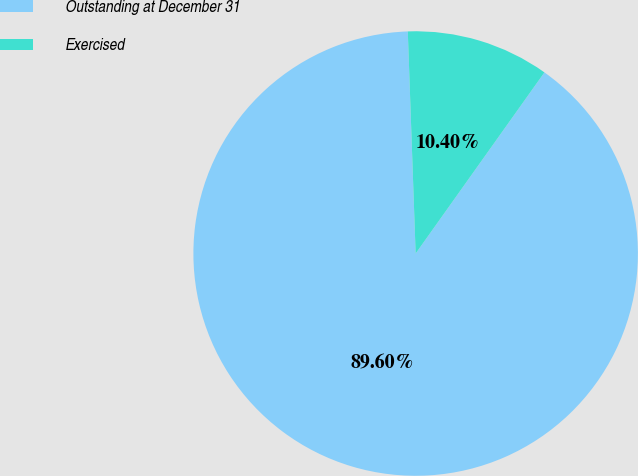<chart> <loc_0><loc_0><loc_500><loc_500><pie_chart><fcel>Outstanding at December 31<fcel>Exercised<nl><fcel>89.6%<fcel>10.4%<nl></chart> 